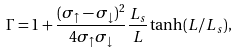<formula> <loc_0><loc_0><loc_500><loc_500>\Gamma = 1 + \frac { ( \sigma _ { \uparrow } - \sigma _ { \downarrow } ) ^ { 2 } } { 4 \sigma _ { \uparrow } \sigma _ { \downarrow } } \frac { L _ { s } } { L } \tanh ( L / L _ { s } ) ,</formula> 